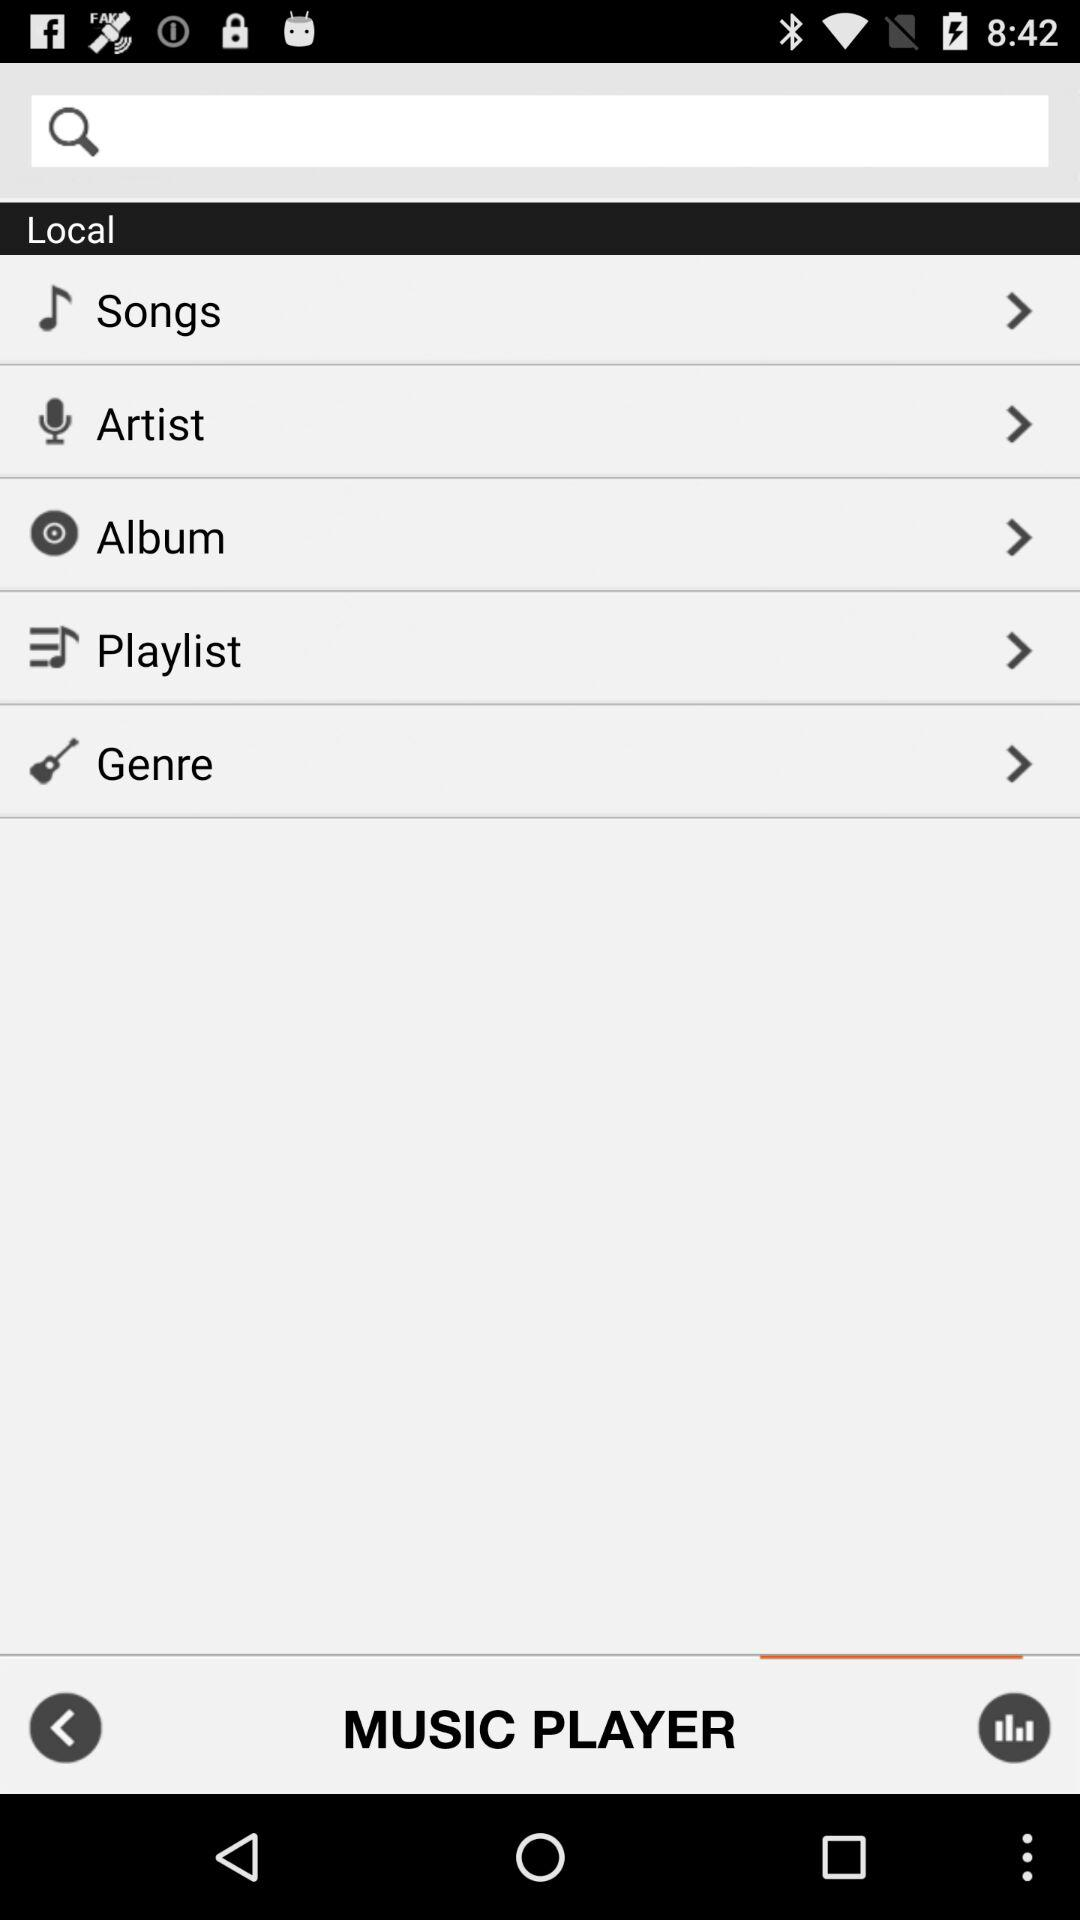What is the name of the application? The name of the application is "MUSIC PLAYER". 